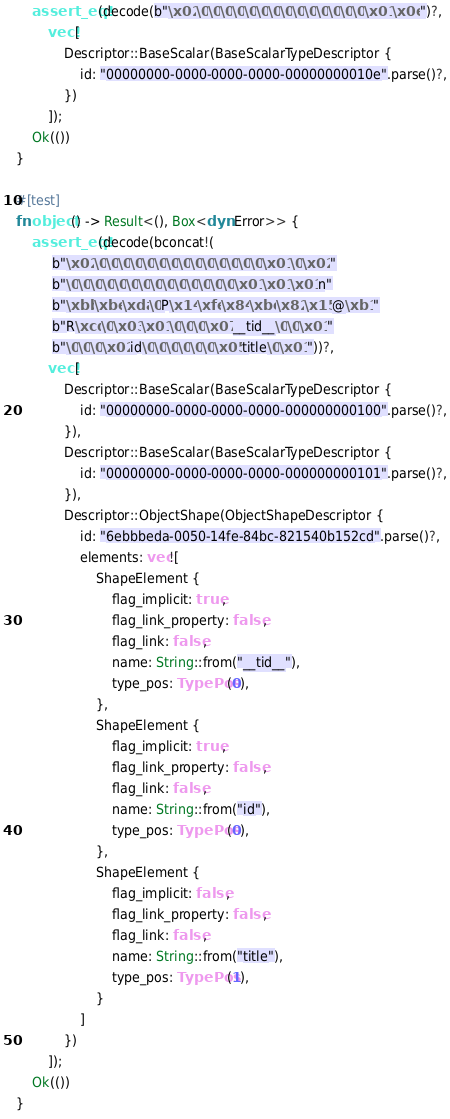Convert code to text. <code><loc_0><loc_0><loc_500><loc_500><_Rust_>    assert_eq!(decode(b"\x02\0\0\0\0\0\0\0\0\0\0\0\0\0\0\x01\x0e")?,
        vec![
            Descriptor::BaseScalar(BaseScalarTypeDescriptor {
                id: "00000000-0000-0000-0000-00000000010e".parse()?,
            })
        ]);
    Ok(())
}

#[test]
fn object() -> Result<(), Box<dyn Error>> {
    assert_eq!(decode(bconcat!(
         b"\x02\0\0\0\0\0\0\0\0\0\0\0\0\0\0\x01\0\x02"
         b"\0\0\0\0\0\0\0\0\0\0\0\0\0\0\x01\x01\x01n"
         b"\xbb\xbe\xda\0P\x14\xfe\x84\xbc\x82\x15@\xb1"
         b"R\xcd\0\x03\x01\0\0\0\x07__tid__\0\0\x01"
         b"\0\0\0\x02id\0\0\0\0\0\0\x05title\0\x01"))?,
        vec![
            Descriptor::BaseScalar(BaseScalarTypeDescriptor {
                id: "00000000-0000-0000-0000-000000000100".parse()?,
            }),
            Descriptor::BaseScalar(BaseScalarTypeDescriptor {
                id: "00000000-0000-0000-0000-000000000101".parse()?,
            }),
            Descriptor::ObjectShape(ObjectShapeDescriptor {
                id: "6ebbbeda-0050-14fe-84bc-821540b152cd".parse()?,
                elements: vec![
                    ShapeElement {
                        flag_implicit: true,
                        flag_link_property: false,
                        flag_link: false,
                        name: String::from("__tid__"),
                        type_pos: TypePos(0),
                    },
                    ShapeElement {
                        flag_implicit: true,
                        flag_link_property: false,
                        flag_link: false,
                        name: String::from("id"),
                        type_pos: TypePos(0),
                    },
                    ShapeElement {
                        flag_implicit: false,
                        flag_link_property: false,
                        flag_link: false,
                        name: String::from("title"),
                        type_pos: TypePos(1),
                    }
                ]
            })
        ]);
    Ok(())
}
</code> 